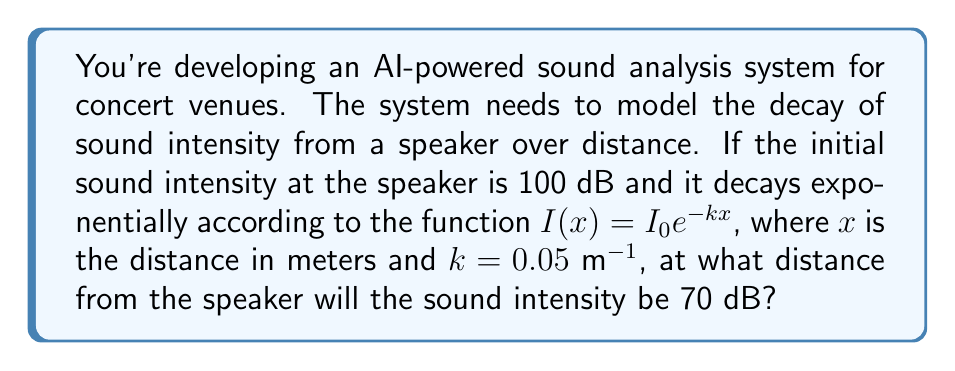Teach me how to tackle this problem. Let's approach this step-by-step:

1) The exponential decay function for sound intensity is given by:
   $$I(x) = I_0 e^{-kx}$$
   where $I_0$ is the initial intensity, $k$ is the decay constant, and $x$ is the distance.

2) We're given:
   $I_0 = 100$ dB
   $k = 0.05$ m^(-1)
   $I(x) = 70$ dB (the intensity we're solving for)

3) Let's substitute these values into the equation:
   $$70 = 100 e^{-0.05x}$$

4) Divide both sides by 100:
   $$0.7 = e^{-0.05x}$$

5) Take the natural logarithm of both sides:
   $$\ln(0.7) = -0.05x$$

6) Solve for $x$:
   $$x = -\frac{\ln(0.7)}{0.05}$$

7) Calculate the result:
   $$x = -\frac{-0.35667}{0.05} \approx 7.13$$

Therefore, the sound intensity will be 70 dB at approximately 7.13 meters from the speaker.
Answer: 7.13 meters 